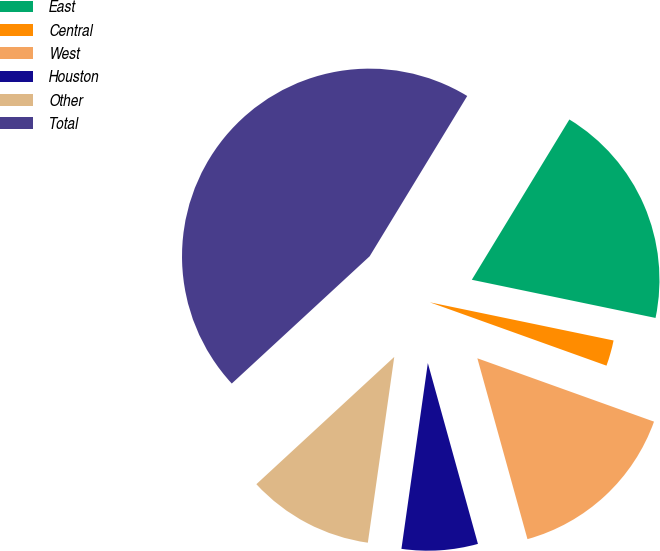Convert chart to OTSL. <chart><loc_0><loc_0><loc_500><loc_500><pie_chart><fcel>East<fcel>Central<fcel>West<fcel>Houston<fcel>Other<fcel>Total<nl><fcel>19.56%<fcel>2.22%<fcel>15.22%<fcel>6.55%<fcel>10.89%<fcel>45.57%<nl></chart> 